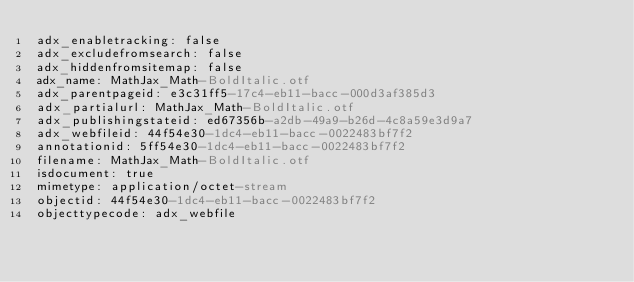Convert code to text. <code><loc_0><loc_0><loc_500><loc_500><_YAML_>adx_enabletracking: false
adx_excludefromsearch: false
adx_hiddenfromsitemap: false
adx_name: MathJax_Math-BoldItalic.otf
adx_parentpageid: e3c31ff5-17c4-eb11-bacc-000d3af385d3
adx_partialurl: MathJax_Math-BoldItalic.otf
adx_publishingstateid: ed67356b-a2db-49a9-b26d-4c8a59e3d9a7
adx_webfileid: 44f54e30-1dc4-eb11-bacc-0022483bf7f2
annotationid: 5ff54e30-1dc4-eb11-bacc-0022483bf7f2
filename: MathJax_Math-BoldItalic.otf
isdocument: true
mimetype: application/octet-stream
objectid: 44f54e30-1dc4-eb11-bacc-0022483bf7f2
objecttypecode: adx_webfile
</code> 